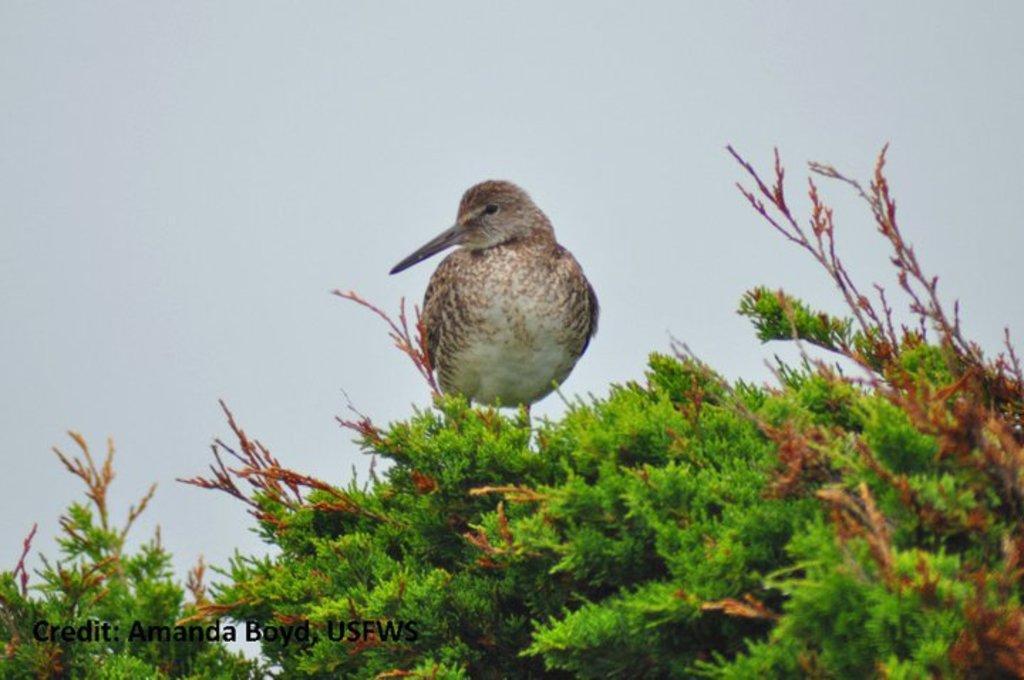In one or two sentences, can you explain what this image depicts? In this image there is a bird sitting at the top of a tree also there is some text at the bottom. 